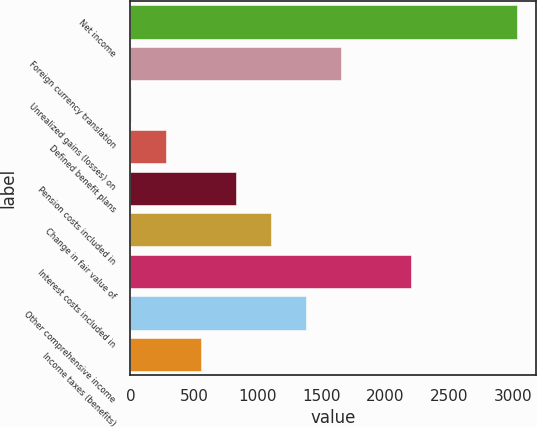<chart> <loc_0><loc_0><loc_500><loc_500><bar_chart><fcel>Net income<fcel>Foreign currency translation<fcel>Unrealized gains (losses) on<fcel>Defined benefit plans<fcel>Pension costs included in<fcel>Change in fair value of<fcel>Interest costs included in<fcel>Other comprehensive income<fcel>Income taxes (benefits)<nl><fcel>3029.3<fcel>1652.8<fcel>1<fcel>276.3<fcel>826.9<fcel>1102.2<fcel>2203.4<fcel>1377.5<fcel>551.6<nl></chart> 